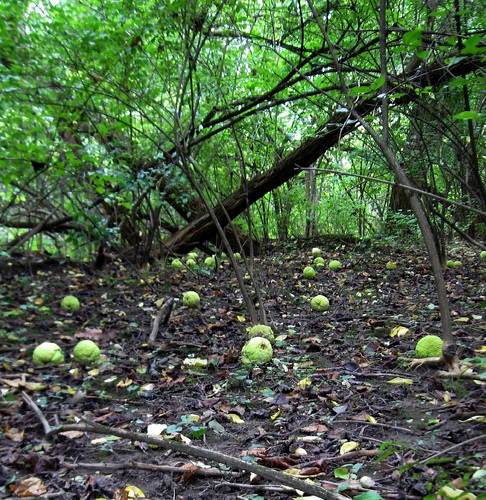<image>
Is the stick on the ground? Yes. Looking at the image, I can see the stick is positioned on top of the ground, with the ground providing support. 